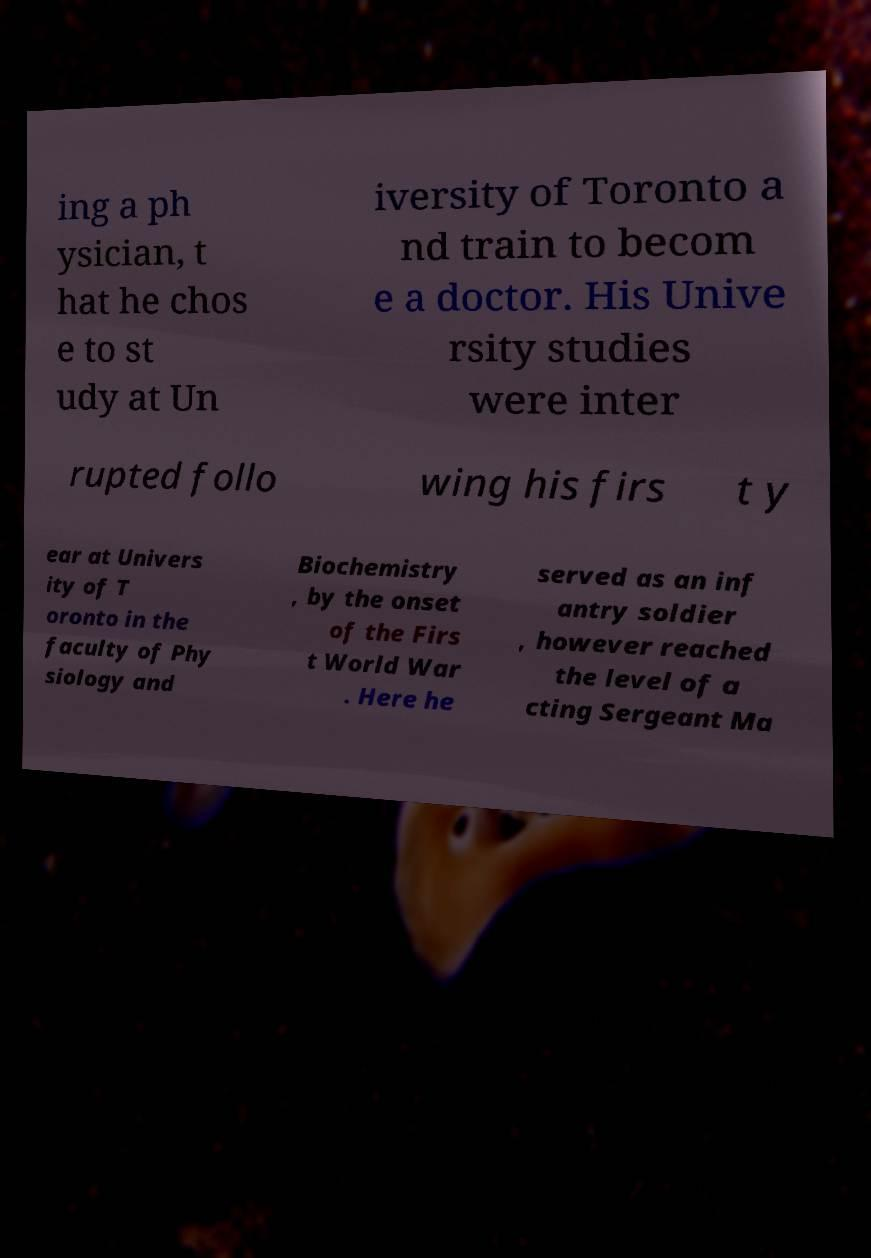Please read and relay the text visible in this image. What does it say? ing a ph ysician, t hat he chos e to st udy at Un iversity of Toronto a nd train to becom e a doctor. His Unive rsity studies were inter rupted follo wing his firs t y ear at Univers ity of T oronto in the faculty of Phy siology and Biochemistry , by the onset of the Firs t World War . Here he served as an inf antry soldier , however reached the level of a cting Sergeant Ma 